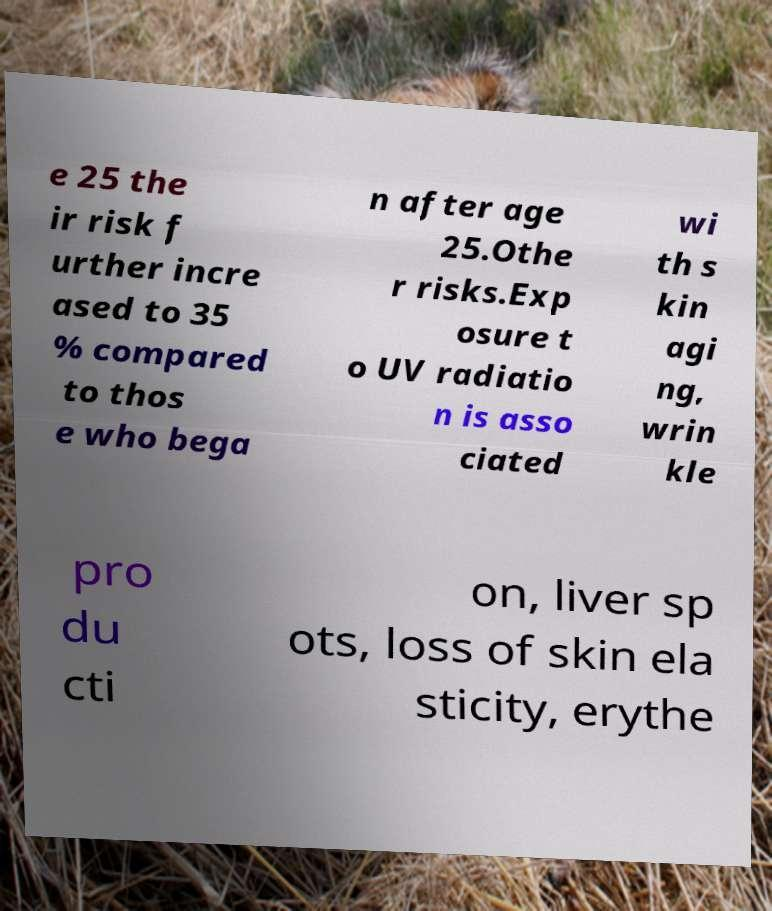Could you assist in decoding the text presented in this image and type it out clearly? e 25 the ir risk f urther incre ased to 35 % compared to thos e who bega n after age 25.Othe r risks.Exp osure t o UV radiatio n is asso ciated wi th s kin agi ng, wrin kle pro du cti on, liver sp ots, loss of skin ela sticity, erythe 